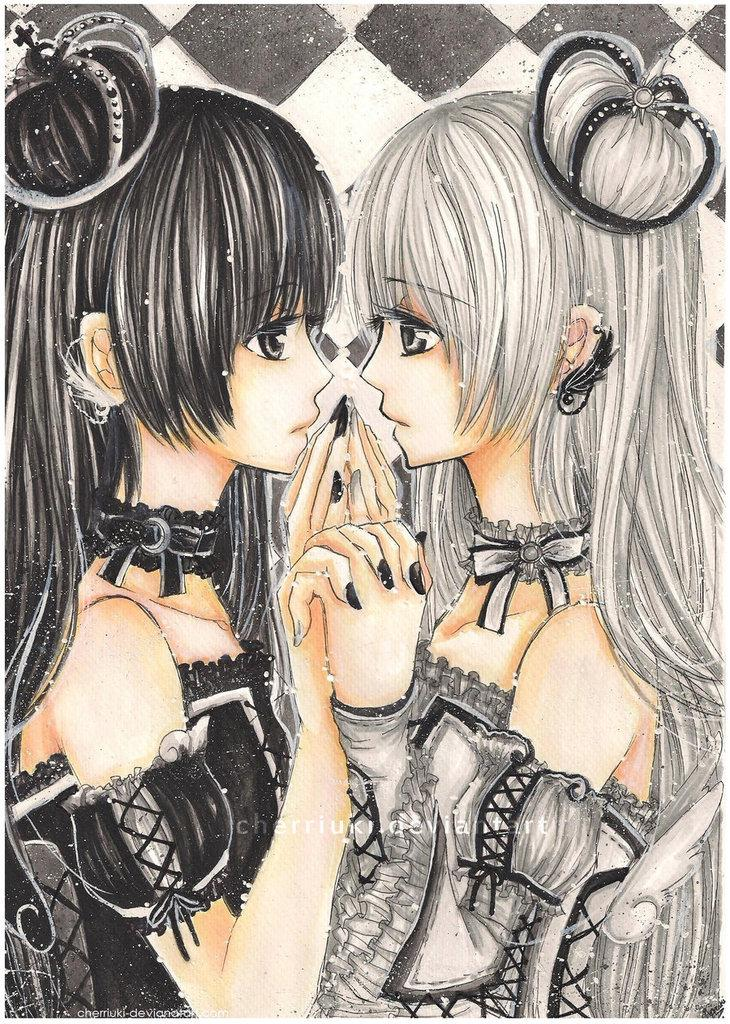What type of content is present in the image? The image contains a cartoon. Can you describe the characters in the cartoon? There are two girls in the cartoon. What is the value of the doll in the image? There is no doll present in the image, so it is not possible to determine its value. 